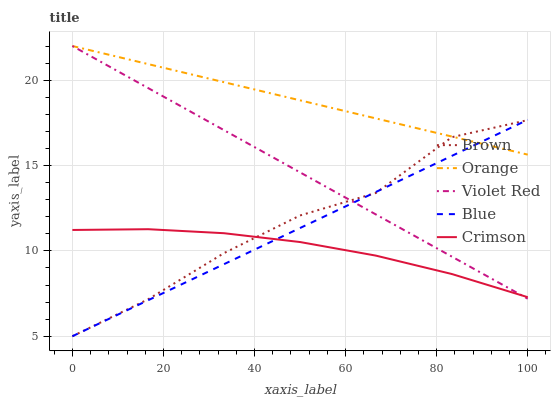Does Crimson have the minimum area under the curve?
Answer yes or no. Yes. Does Orange have the maximum area under the curve?
Answer yes or no. Yes. Does Brown have the minimum area under the curve?
Answer yes or no. No. Does Brown have the maximum area under the curve?
Answer yes or no. No. Is Blue the smoothest?
Answer yes or no. Yes. Is Brown the roughest?
Answer yes or no. Yes. Is Violet Red the smoothest?
Answer yes or no. No. Is Violet Red the roughest?
Answer yes or no. No. Does Brown have the lowest value?
Answer yes or no. Yes. Does Violet Red have the lowest value?
Answer yes or no. No. Does Violet Red have the highest value?
Answer yes or no. Yes. Does Brown have the highest value?
Answer yes or no. No. Is Crimson less than Orange?
Answer yes or no. Yes. Is Orange greater than Crimson?
Answer yes or no. Yes. Does Violet Red intersect Brown?
Answer yes or no. Yes. Is Violet Red less than Brown?
Answer yes or no. No. Is Violet Red greater than Brown?
Answer yes or no. No. Does Crimson intersect Orange?
Answer yes or no. No. 